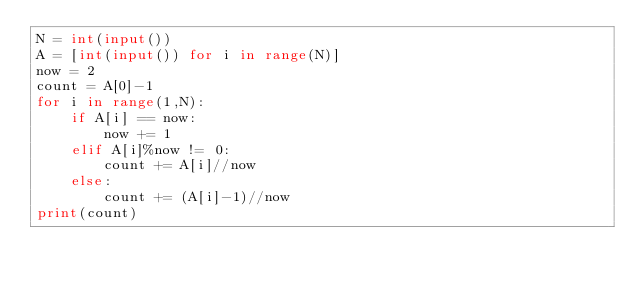Convert code to text. <code><loc_0><loc_0><loc_500><loc_500><_Python_>N = int(input())
A = [int(input()) for i in range(N)]
now = 2
count = A[0]-1
for i in range(1,N):
    if A[i] == now:
        now += 1
    elif A[i]%now != 0:
        count += A[i]//now
    else:
        count += (A[i]-1)//now
print(count)</code> 